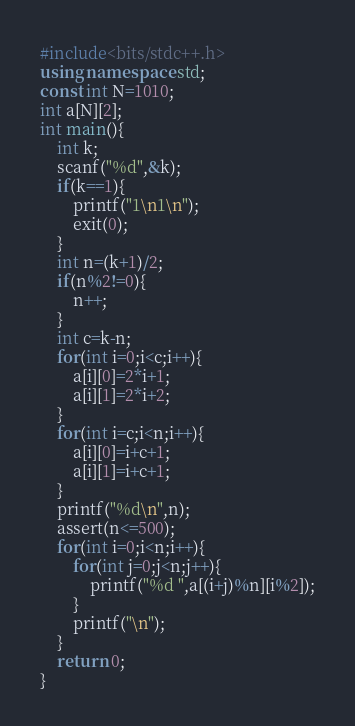Convert code to text. <code><loc_0><loc_0><loc_500><loc_500><_C++_>#include<bits/stdc++.h>
using namespace std;
const int N=1010;
int a[N][2];
int main(){
	int k;
	scanf("%d",&k);
	if(k==1){
		printf("1\n1\n");
		exit(0);
	}
	int n=(k+1)/2;
	if(n%2!=0){
		n++;
	}
	int c=k-n;
	for(int i=0;i<c;i++){
		a[i][0]=2*i+1;
		a[i][1]=2*i+2;
	}
	for(int i=c;i<n;i++){
		a[i][0]=i+c+1;
		a[i][1]=i+c+1;
	}
	printf("%d\n",n);
	assert(n<=500);
	for(int i=0;i<n;i++){
		for(int j=0;j<n;j++){
			printf("%d ",a[(i+j)%n][i%2]);
		}
		printf("\n");
	}
	return 0;
}</code> 